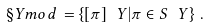<formula> <loc_0><loc_0><loc_500><loc_500>\S Y m o d \, = \left \{ [ \pi ] _ { \ } Y | \pi \in S _ { \ } Y \right \} \, .</formula> 